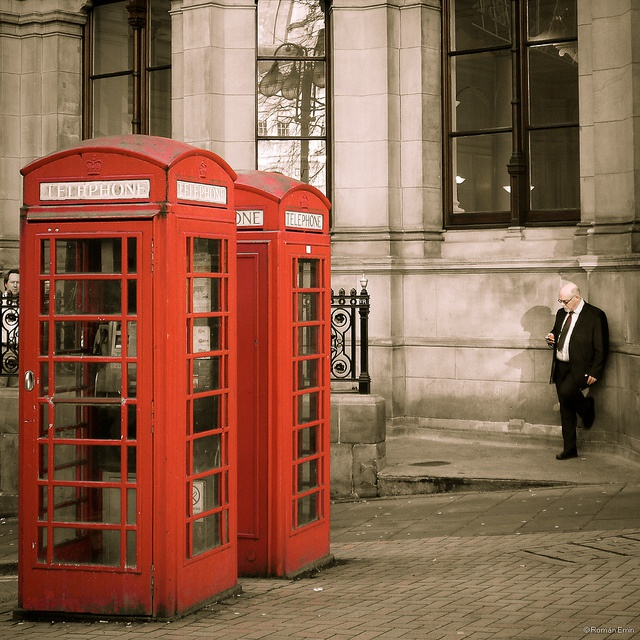Describe the objects in this image and their specific colors. I can see people in gray, black, lightgray, and tan tones, people in gray, black, and tan tones, tie in gray, black, and maroon tones, and cell phone in gray, black, tan, lightgray, and brown tones in this image. 